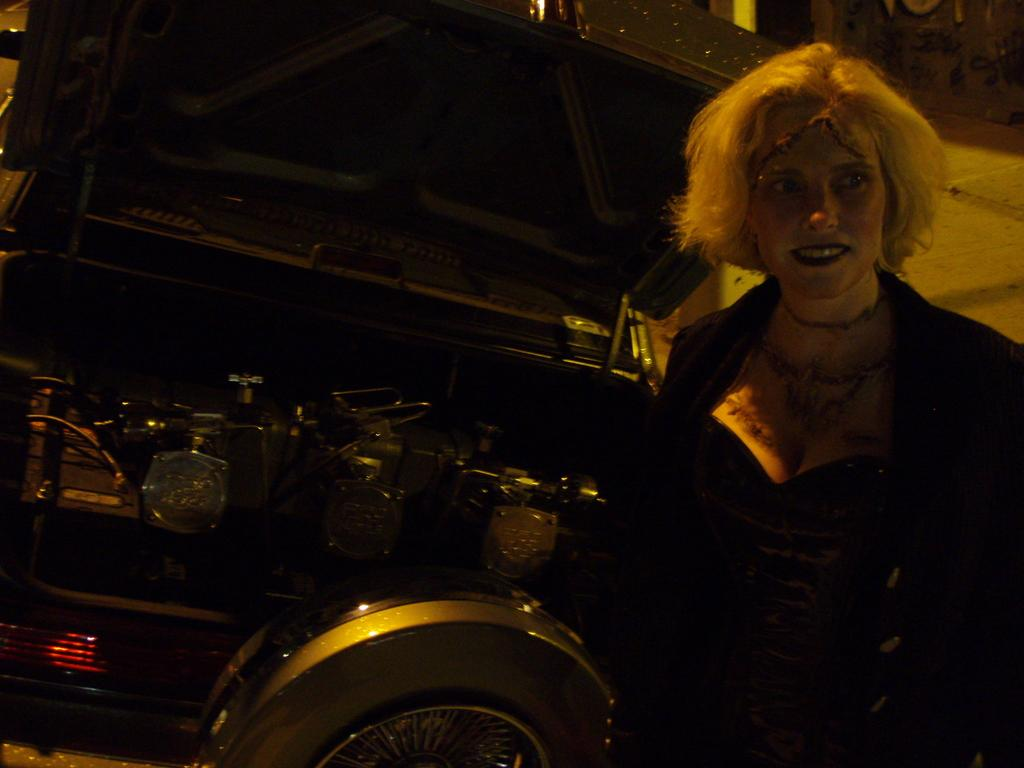Who is present in the image? There is a woman in the image. What is the woman wearing? The woman is wearing a black dress. What can be seen in the background of the image? There is a black object or area in the background of the image. How would you describe the lighting in the image? The image appears to be slightly dark. What type of needle is being used to sew the scene in the image? There is no needle or sewing activity present in the image. The woman is not depicted sewing or working with a needle. 